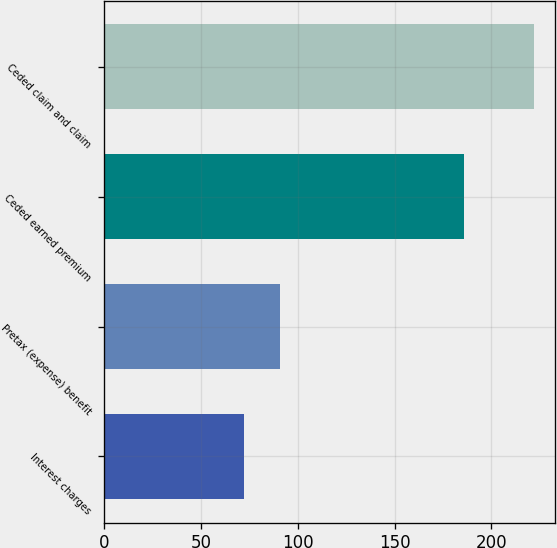Convert chart to OTSL. <chart><loc_0><loc_0><loc_500><loc_500><bar_chart><fcel>Interest charges<fcel>Pretax (expense) benefit<fcel>Ceded earned premium<fcel>Ceded claim and claim<nl><fcel>72<fcel>90.8<fcel>185.8<fcel>222<nl></chart> 